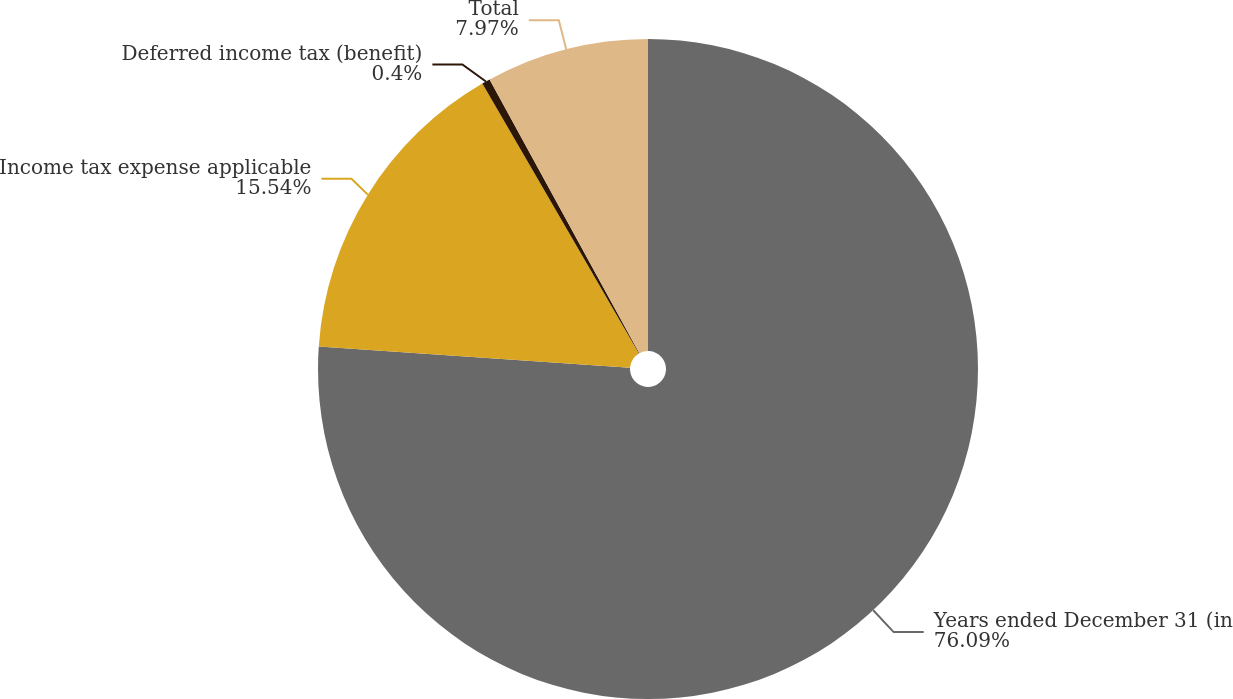<chart> <loc_0><loc_0><loc_500><loc_500><pie_chart><fcel>Years ended December 31 (in<fcel>Income tax expense applicable<fcel>Deferred income tax (benefit)<fcel>Total<nl><fcel>76.09%<fcel>15.54%<fcel>0.4%<fcel>7.97%<nl></chart> 